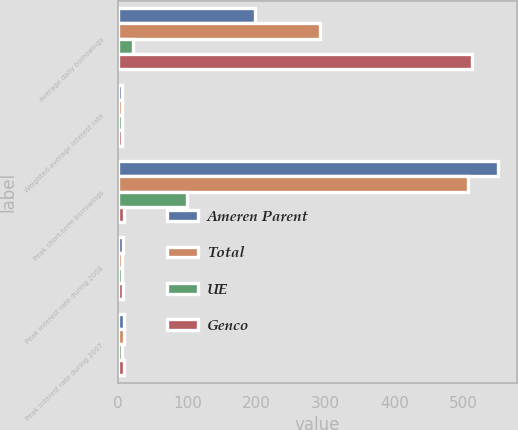Convert chart to OTSL. <chart><loc_0><loc_0><loc_500><loc_500><stacked_bar_chart><ecel><fcel>Average daily borrowings<fcel>Weighted-average interest rate<fcel>Peak short-term borrowings<fcel>Peak interest rate during 2008<fcel>Peak interest rate during 2007<nl><fcel>Ameren Parent<fcel>198<fcel>5.75<fcel>550<fcel>7.25<fcel>8.25<nl><fcel>Total<fcel>292<fcel>5.66<fcel>506<fcel>5.65<fcel>8.25<nl><fcel>UE<fcel>22<fcel>5.43<fcel>100<fcel>5.53<fcel>5.76<nl><fcel>Genco<fcel>512<fcel>5.68<fcel>8.25<fcel>7.25<fcel>8.25<nl></chart> 